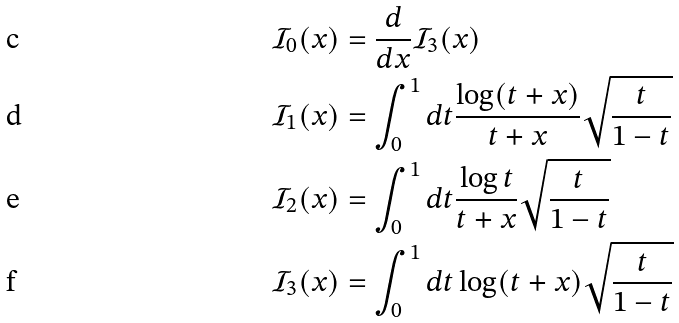<formula> <loc_0><loc_0><loc_500><loc_500>\mathcal { I } _ { 0 } ( x ) & = \frac { d } { d x } \mathcal { I } _ { 3 } ( x ) \\ \mathcal { I } _ { 1 } ( x ) & = \int _ { 0 } ^ { 1 } d t \frac { \log ( t + x ) } { t + x } \sqrt { \frac { t } { 1 - t } } \\ \mathcal { I } _ { 2 } ( x ) & = \int _ { 0 } ^ { 1 } d t \frac { \log t } { t + x } \sqrt { \frac { t } { 1 - t } } \\ \mathcal { I } _ { 3 } ( x ) & = \int _ { 0 } ^ { 1 } d t \log ( t + x ) \sqrt { \frac { t } { 1 - t } }</formula> 